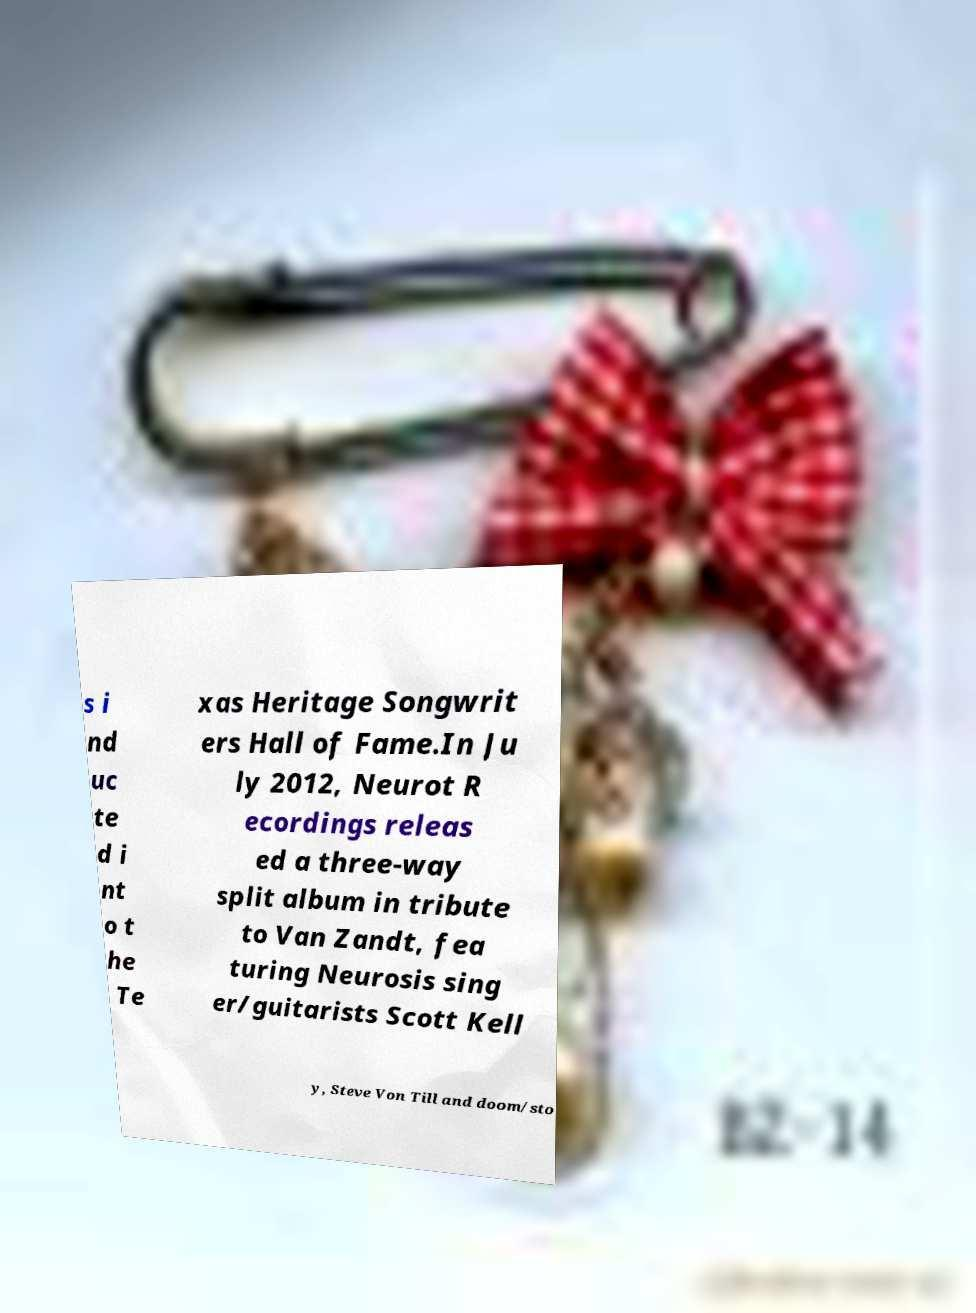There's text embedded in this image that I need extracted. Can you transcribe it verbatim? s i nd uc te d i nt o t he Te xas Heritage Songwrit ers Hall of Fame.In Ju ly 2012, Neurot R ecordings releas ed a three-way split album in tribute to Van Zandt, fea turing Neurosis sing er/guitarists Scott Kell y, Steve Von Till and doom/sto 